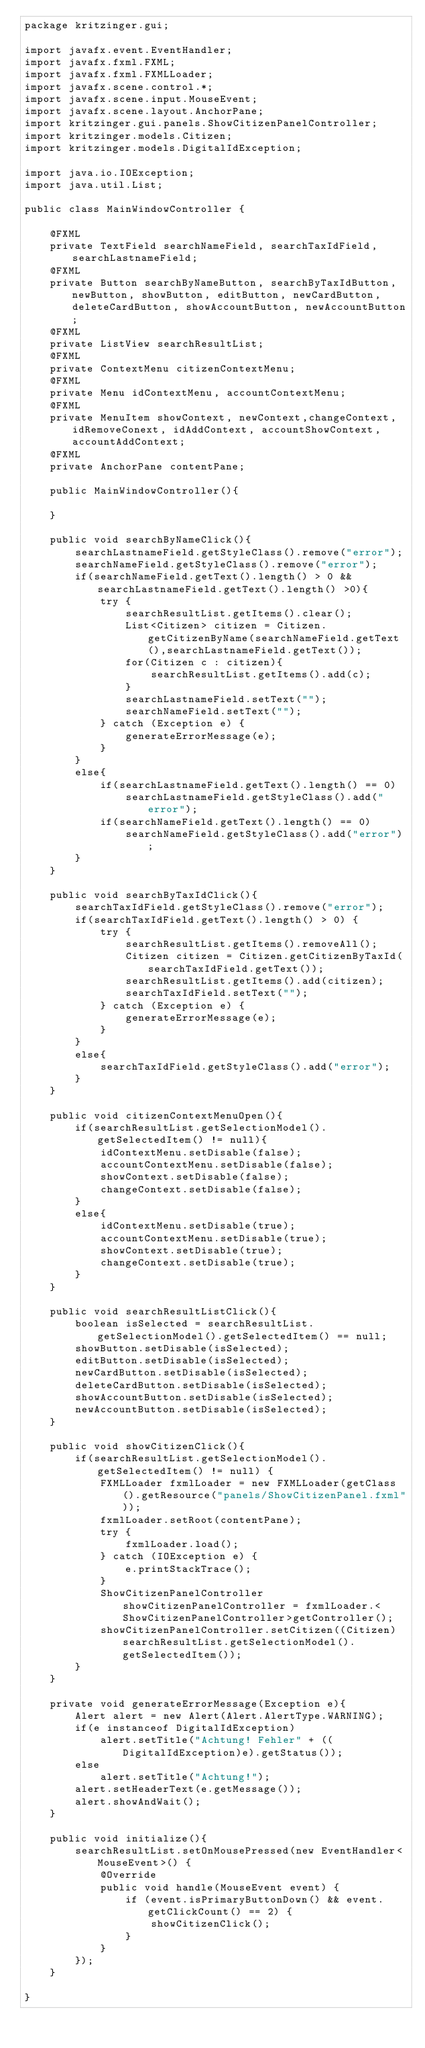<code> <loc_0><loc_0><loc_500><loc_500><_Java_>package kritzinger.gui;

import javafx.event.EventHandler;
import javafx.fxml.FXML;
import javafx.fxml.FXMLLoader;
import javafx.scene.control.*;
import javafx.scene.input.MouseEvent;
import javafx.scene.layout.AnchorPane;
import kritzinger.gui.panels.ShowCitizenPanelController;
import kritzinger.models.Citizen;
import kritzinger.models.DigitalIdException;

import java.io.IOException;
import java.util.List;

public class MainWindowController {

    @FXML
    private TextField searchNameField, searchTaxIdField, searchLastnameField;
    @FXML
    private Button searchByNameButton, searchByTaxIdButton, newButton, showButton, editButton, newCardButton, deleteCardButton, showAccountButton, newAccountButton;
    @FXML
    private ListView searchResultList;
    @FXML
    private ContextMenu citizenContextMenu;
    @FXML
    private Menu idContextMenu, accountContextMenu;
    @FXML
    private MenuItem showContext, newContext,changeContext, idRemoveConext, idAddContext, accountShowContext, accountAddContext;
    @FXML
    private AnchorPane contentPane;

    public MainWindowController(){

    }

    public void searchByNameClick(){
        searchLastnameField.getStyleClass().remove("error");
        searchNameField.getStyleClass().remove("error");
        if(searchNameField.getText().length() > 0 && searchLastnameField.getText().length() >0){
            try {
                searchResultList.getItems().clear();
                List<Citizen> citizen = Citizen.getCitizenByName(searchNameField.getText(),searchLastnameField.getText());
                for(Citizen c : citizen){
                    searchResultList.getItems().add(c);
                }
                searchLastnameField.setText("");
                searchNameField.setText("");
            } catch (Exception e) {
                generateErrorMessage(e);
            }
        }
        else{
            if(searchLastnameField.getText().length() == 0)
                searchLastnameField.getStyleClass().add("error");
            if(searchNameField.getText().length() == 0)
                searchNameField.getStyleClass().add("error");
        }
    }

    public void searchByTaxIdClick(){
        searchTaxIdField.getStyleClass().remove("error");
        if(searchTaxIdField.getText().length() > 0) {
            try {
                searchResultList.getItems().removeAll();
                Citizen citizen = Citizen.getCitizenByTaxId(searchTaxIdField.getText());
                searchResultList.getItems().add(citizen);
                searchTaxIdField.setText("");
            } catch (Exception e) {
                generateErrorMessage(e);
            }
        }
        else{
            searchTaxIdField.getStyleClass().add("error");
        }
    }

    public void citizenContextMenuOpen(){
        if(searchResultList.getSelectionModel().getSelectedItem() != null){
            idContextMenu.setDisable(false);
            accountContextMenu.setDisable(false);
            showContext.setDisable(false);
            changeContext.setDisable(false);
        }
        else{
            idContextMenu.setDisable(true);
            accountContextMenu.setDisable(true);
            showContext.setDisable(true);
            changeContext.setDisable(true);
        }
    }

    public void searchResultListClick(){
        boolean isSelected = searchResultList.getSelectionModel().getSelectedItem() == null;
        showButton.setDisable(isSelected);
        editButton.setDisable(isSelected);
        newCardButton.setDisable(isSelected);
        deleteCardButton.setDisable(isSelected);
        showAccountButton.setDisable(isSelected);
        newAccountButton.setDisable(isSelected);
    }

    public void showCitizenClick(){
        if(searchResultList.getSelectionModel().getSelectedItem() != null) {
            FXMLLoader fxmlLoader = new FXMLLoader(getClass().getResource("panels/ShowCitizenPanel.fxml"));
            fxmlLoader.setRoot(contentPane);
            try {
                fxmlLoader.load();
            } catch (IOException e) {
                e.printStackTrace();
            }
            ShowCitizenPanelController showCitizenPanelController = fxmlLoader.<ShowCitizenPanelController>getController();
            showCitizenPanelController.setCitizen((Citizen) searchResultList.getSelectionModel().getSelectedItem());
        }
    }

    private void generateErrorMessage(Exception e){
        Alert alert = new Alert(Alert.AlertType.WARNING);
        if(e instanceof DigitalIdException)
            alert.setTitle("Achtung! Fehler" + ((DigitalIdException)e).getStatus());
        else
            alert.setTitle("Achtung!");
        alert.setHeaderText(e.getMessage());
        alert.showAndWait();
    }

    public void initialize(){
        searchResultList.setOnMousePressed(new EventHandler<MouseEvent>() {
            @Override
            public void handle(MouseEvent event) {
                if (event.isPrimaryButtonDown() && event.getClickCount() == 2) {
                    showCitizenClick();
                }
            }
        });
    }

}
</code> 